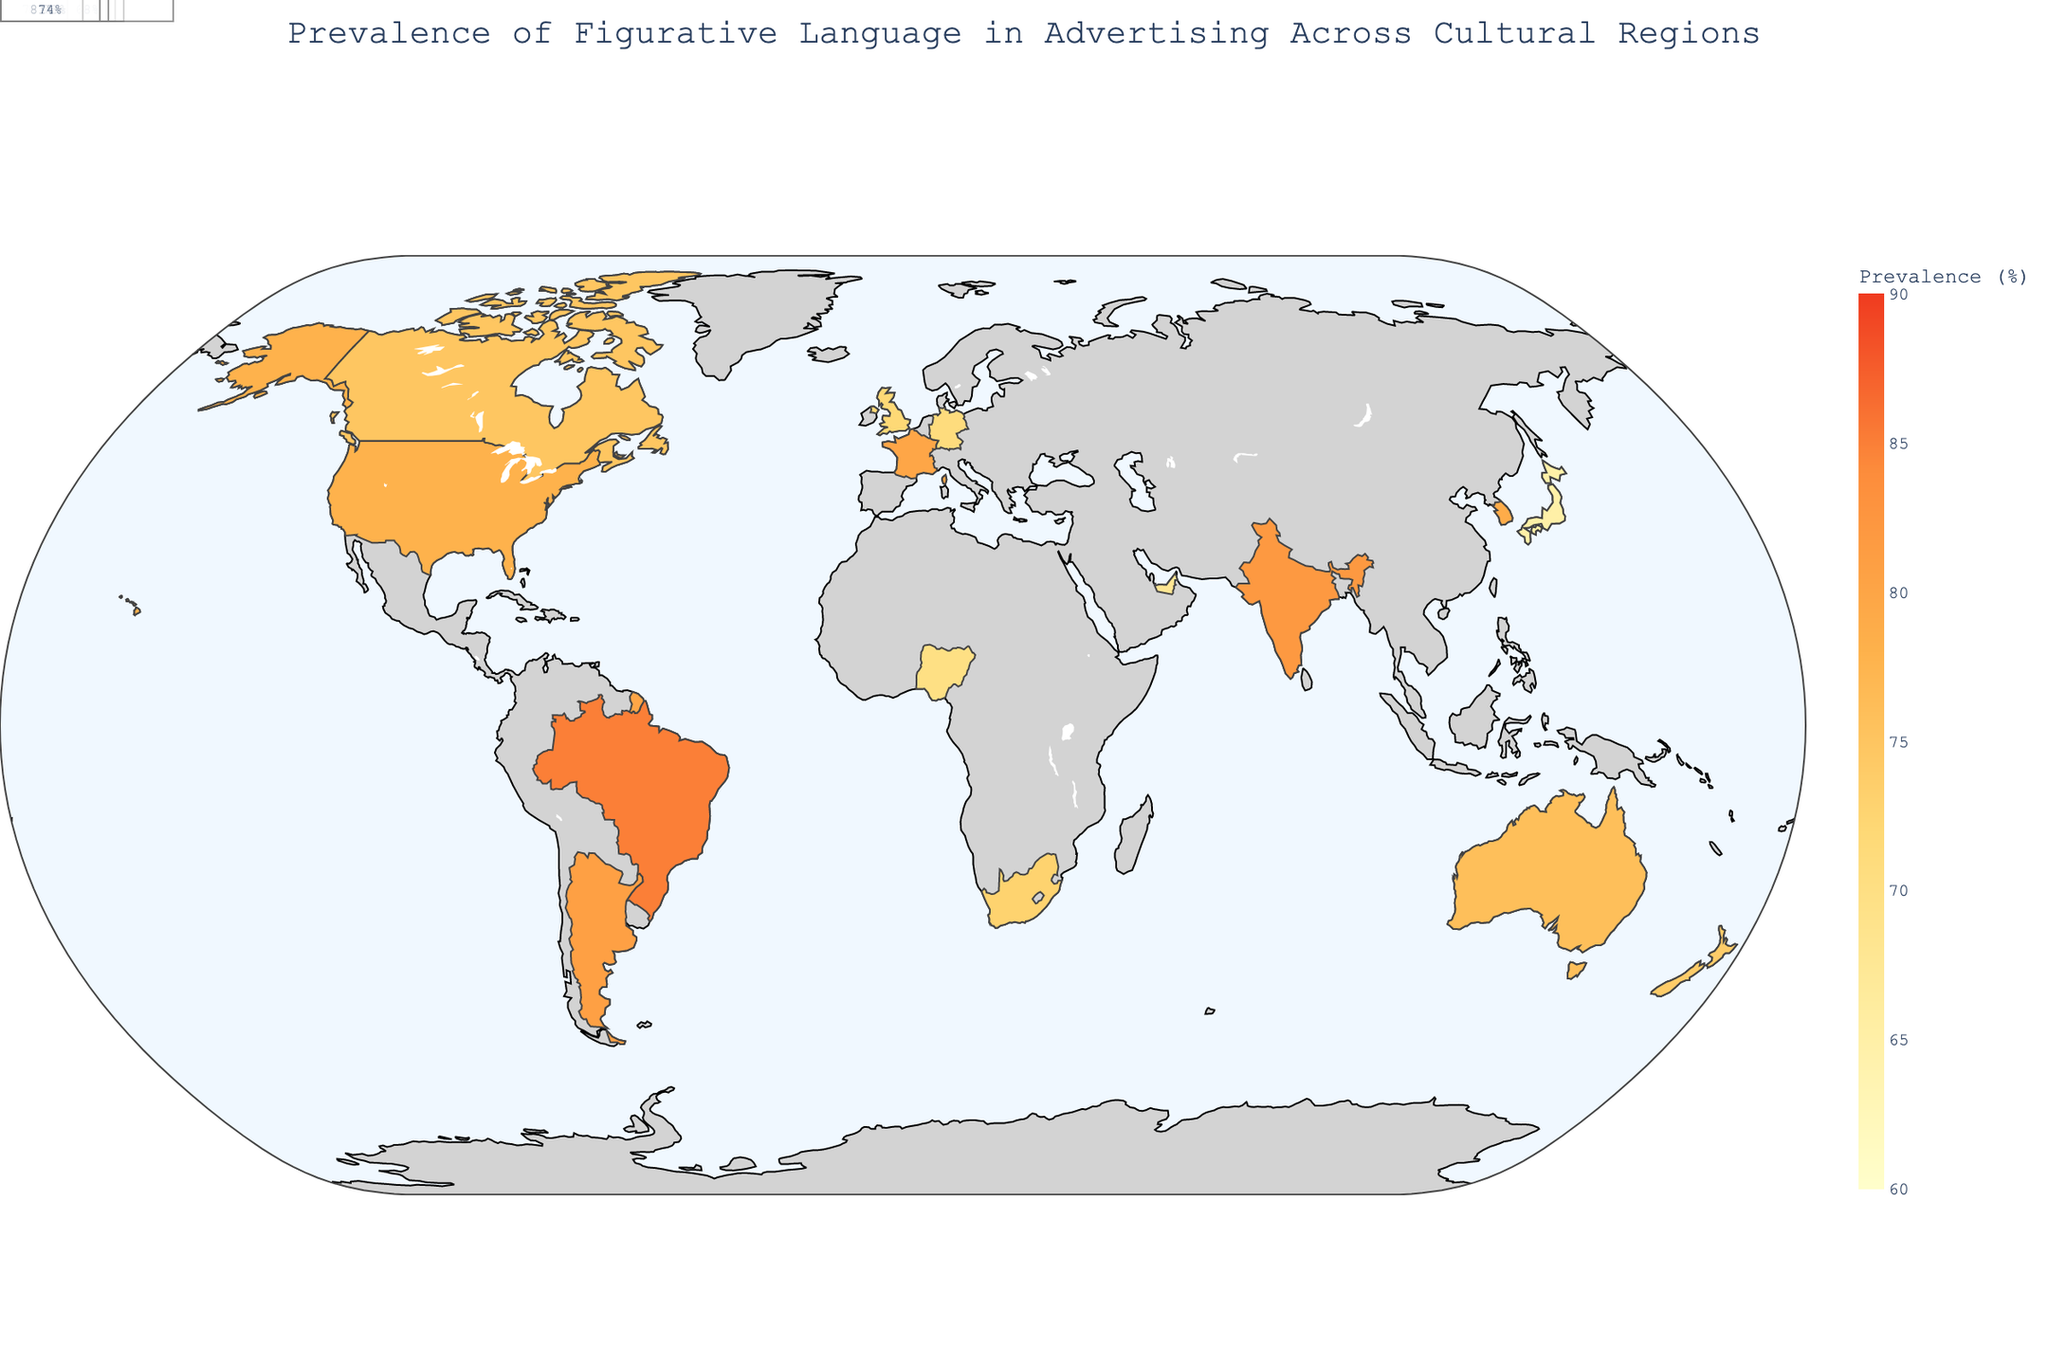what is the title of the figure? The title is usually positioned at the top of a plot. Here, it reads "Prevalence of Figurative Language in Advertising Across Cultural Regions."
Answer: Prevalence of Figurative Language in Advertising Across Cultural Regions which country in Europe has the highest prevalence of figurative language in advertising? By looking at the countries in Europe and their prevalence values, France has the highest prevalence at 80%.
Answer: France what is the dominant type of figurative language used in the United States? By examining the hover data linked with the United States on the map, it shows "Dominant_Type: Metaphor."
Answer: Metaphor how many countries in Asia are displayed in the figure? Checking the regions listed, Asia contains Japan, India, and South Korea, totaling three countries.
Answer: 3 what is the emotional impact associated with hyperbole in South America? By looking at the hover data for Brazil in South America, the emotional impact listed is "Very High."
Answer: Very High which country in North America has the higher prevalence of figurative language, the United States or Canada? Comparing the prevalence values for both countries in North America, the United States (78%) is higher than Canada (75%).
Answer: United States what is the average prevalence of figurative language in the countries from Oceania? Oceania includes Australia (76%) and New Zealand (74%). Calculating the average: (76 + 74) / 2 = 75%.
Answer: 75% which country has the lowest prevalence of figurative language in advertising? By comparing the prevalence values, Japan has the lowest value at 65%.
Answer: Japan do more countries have a high emotional impact than moderate emotional impact? By counting the emotional impacts listed: High (United States, Nigeria, France, South Korea, Argentina) = 5, Moderate (United Kingdom, Australia, Germany, Canada, South Africa, New Zealand) = 6. Therefore, more countries have a moderate emotional impact compared to high.
Answer: No what is the difference in figurative language prevalence between the country with the highest value and the country with the lowest value? The highest prevalence is in Brazil (85%) and the lowest in Japan (65%). The difference is 85 - 65 = 20%.
Answer: 20% 